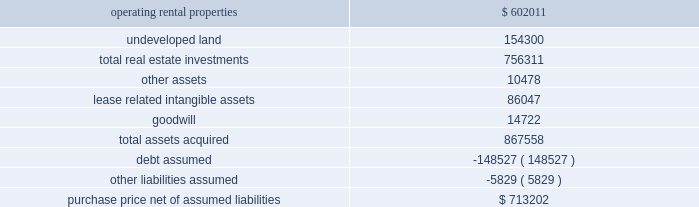As approximately 161 acres of undeveloped land and a 12-acre container storage facility in houston .
The total price was $ 89.7 million and was financed in part through assumption of secured debt that had a fair value of $ 34.3 million .
Of the total purchase price , $ 64.1 million was allocated to in-service real estate assets , $ 20.0 million was allocated to undeveloped land and the container storage facility , $ 5.4 million was allocated to lease related intangible assets , and the remaining amount was allocated to acquired working capital related assets and liabilities .
The results of operations for the acquired properties since the date of acquisition have been included in continuing rental operations in our consolidated financial statements .
In february 2007 , we completed the acquisition of bremner healthcare real estate ( 201cbremner 201d ) , a national health care development and management firm .
The primary reason for the acquisition was to expand our development capabilities within the health care real estate market .
The initial consideration paid to the sellers totaled $ 47.1 million , and the sellers may be eligible for further contingent payments over a three-year period following the acquisition .
Approximately $ 39.0 million of the total purchase price was allocated to goodwill , which is attributable to the value of bremner 2019s overall development capabilities and its in-place workforce .
The results of operations for bremner since the date of acquisition have been included in continuing operations in our consolidated financial statements .
In february 2006 , we acquired the majority of a washington , d.c .
Metropolitan area portfolio of suburban office and light industrial properties ( the 201cmark winkler portfolio 201d ) .
The assets acquired for a purchase price of approximately $ 867.6 million were comprised of 32 in-service properties with approximately 2.9 million square feet for rental , 166 acres of undeveloped land , as well as certain related assets of the mark winkler company , a real estate management company .
The acquisition was financed primarily through assumed mortgage loans and new borrowings .
The assets acquired and liabilities assumed were recorded at their estimated fair value at the date of acquisition , as summarized below ( in thousands ) : .
Purchase price , net of assumed liabilities $ 713202 in december 2006 , we contributed 23 of these in-service properties acquired from the mark winkler portfolio with a basis of $ 381.6 million representing real estate investments and acquired lease related intangible assets to two new unconsolidated subsidiaries .
Of the remaining nine in-service properties , eight were contributed to these two unconsolidated subsidiaries in 2007 and one remains in continuing operations as of december 31 , 2008 .
The eight properties contributed in 2007 had a basis of $ 298.4 million representing real estate investments and acquired lease related intangible assets , and debt secured by these properties of $ 146.4 million was also assumed by the unconsolidated subsidiaries .
In the third quarter of 2006 , we finalized the purchase of a portfolio of industrial real estate properties in savannah , georgia .
We completed a majority of the purchase in january 2006 .
The assets acquired for a purchase price of approximately $ 196.2 million were comprised of 18 buildings with approximately 5.1 million square feet for rental as well as over 60 acres of undeveloped land .
The acquisition was financed in part through assumed mortgage loans .
The results of operations for the acquired properties since the date of acquisition have been included in continuing rental operations in our consolidated financial statements. .
As part of the following purchase of 161 acres of undeveloped land and a 12-acre container storage facility in houstonwhat was the percent of the total purchase price allocated to in-service real estate assets? 
Computations: (64.1 / 89.7)
Answer: 0.7146. 